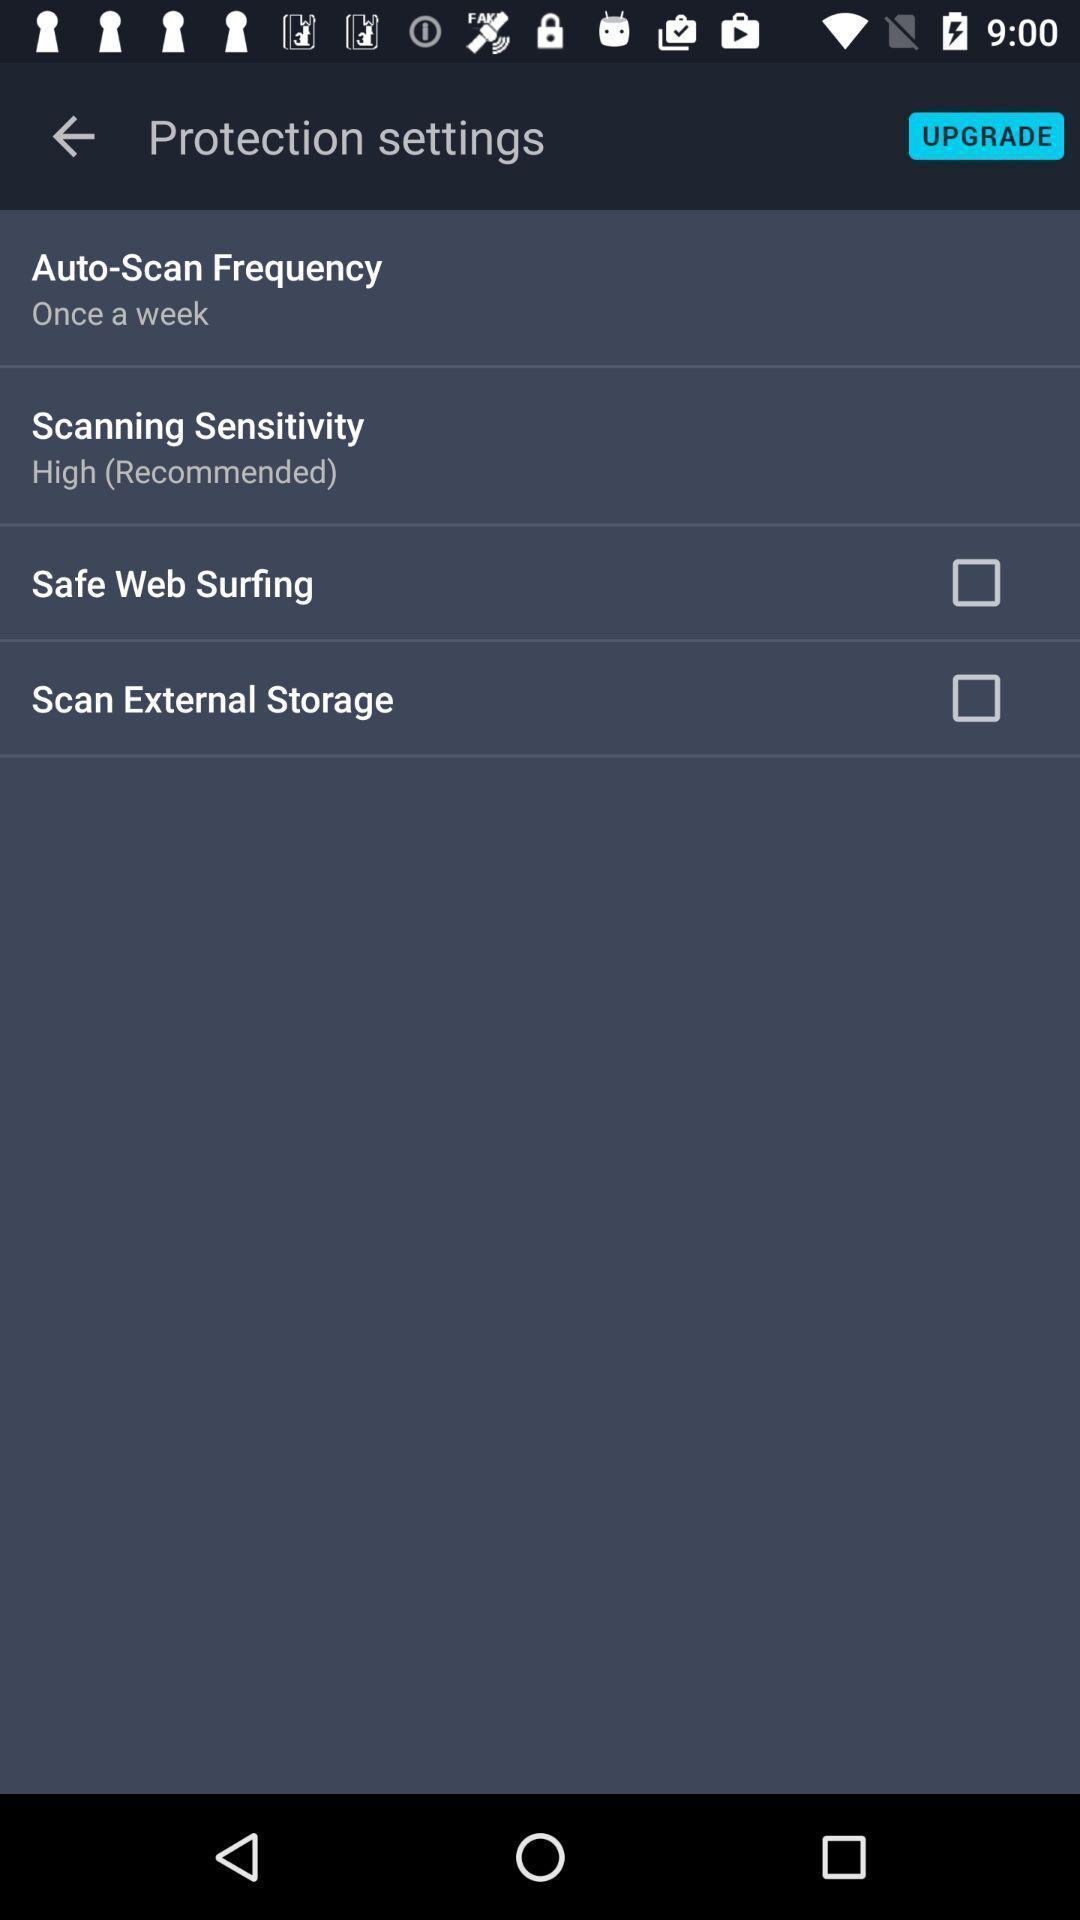Describe the content in this image. Page displaying with list of different settings. 